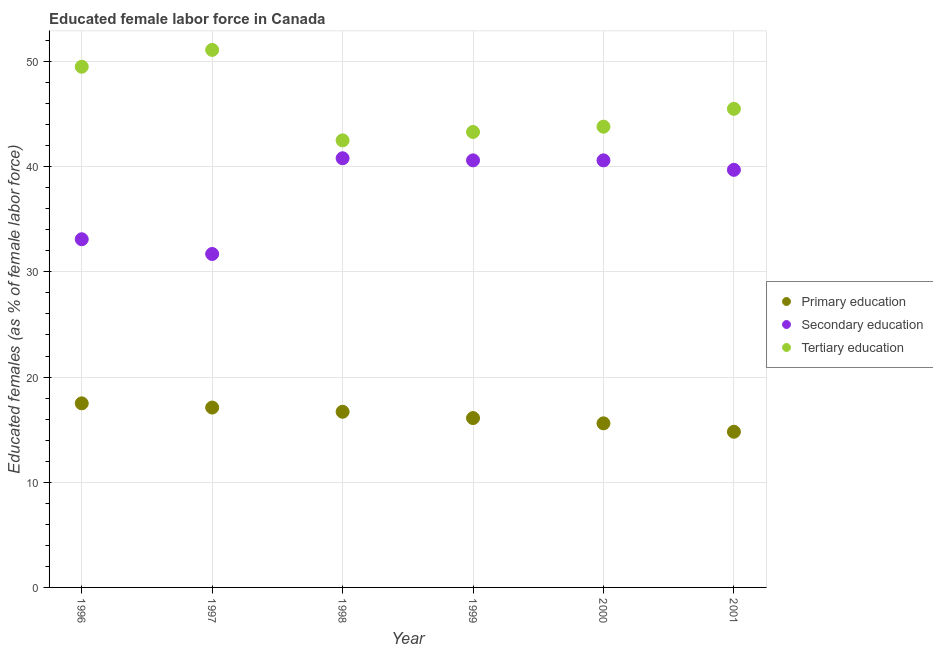Is the number of dotlines equal to the number of legend labels?
Ensure brevity in your answer.  Yes. Across all years, what is the maximum percentage of female labor force who received tertiary education?
Your response must be concise. 51.1. Across all years, what is the minimum percentage of female labor force who received tertiary education?
Ensure brevity in your answer.  42.5. In which year was the percentage of female labor force who received tertiary education maximum?
Offer a very short reply. 1997. What is the total percentage of female labor force who received secondary education in the graph?
Provide a short and direct response. 226.5. What is the difference between the percentage of female labor force who received primary education in 1996 and that in 2001?
Make the answer very short. 2.7. What is the difference between the percentage of female labor force who received tertiary education in 1999 and the percentage of female labor force who received primary education in 1996?
Give a very brief answer. 25.8. What is the average percentage of female labor force who received tertiary education per year?
Provide a short and direct response. 45.95. In the year 2001, what is the difference between the percentage of female labor force who received primary education and percentage of female labor force who received tertiary education?
Ensure brevity in your answer.  -30.7. What is the ratio of the percentage of female labor force who received secondary education in 1997 to that in 1998?
Your response must be concise. 0.78. Is the percentage of female labor force who received primary education in 1997 less than that in 1999?
Your answer should be very brief. No. Is the difference between the percentage of female labor force who received secondary education in 1996 and 2001 greater than the difference between the percentage of female labor force who received tertiary education in 1996 and 2001?
Give a very brief answer. No. What is the difference between the highest and the second highest percentage of female labor force who received secondary education?
Make the answer very short. 0.2. What is the difference between the highest and the lowest percentage of female labor force who received secondary education?
Make the answer very short. 9.1. Is the sum of the percentage of female labor force who received secondary education in 1997 and 2001 greater than the maximum percentage of female labor force who received primary education across all years?
Offer a very short reply. Yes. Does the percentage of female labor force who received secondary education monotonically increase over the years?
Offer a terse response. No. Is the percentage of female labor force who received tertiary education strictly greater than the percentage of female labor force who received secondary education over the years?
Offer a terse response. Yes. Is the percentage of female labor force who received secondary education strictly less than the percentage of female labor force who received tertiary education over the years?
Offer a terse response. Yes. How many dotlines are there?
Your answer should be very brief. 3. How many years are there in the graph?
Make the answer very short. 6. What is the difference between two consecutive major ticks on the Y-axis?
Your answer should be compact. 10. Does the graph contain grids?
Provide a succinct answer. Yes. Where does the legend appear in the graph?
Your answer should be very brief. Center right. What is the title of the graph?
Keep it short and to the point. Educated female labor force in Canada. What is the label or title of the X-axis?
Make the answer very short. Year. What is the label or title of the Y-axis?
Offer a terse response. Educated females (as % of female labor force). What is the Educated females (as % of female labor force) in Secondary education in 1996?
Offer a very short reply. 33.1. What is the Educated females (as % of female labor force) of Tertiary education in 1996?
Offer a very short reply. 49.5. What is the Educated females (as % of female labor force) in Primary education in 1997?
Keep it short and to the point. 17.1. What is the Educated females (as % of female labor force) of Secondary education in 1997?
Your answer should be compact. 31.7. What is the Educated females (as % of female labor force) in Tertiary education in 1997?
Keep it short and to the point. 51.1. What is the Educated females (as % of female labor force) of Primary education in 1998?
Give a very brief answer. 16.7. What is the Educated females (as % of female labor force) in Secondary education in 1998?
Offer a very short reply. 40.8. What is the Educated females (as % of female labor force) of Tertiary education in 1998?
Your answer should be compact. 42.5. What is the Educated females (as % of female labor force) in Primary education in 1999?
Provide a short and direct response. 16.1. What is the Educated females (as % of female labor force) of Secondary education in 1999?
Your response must be concise. 40.6. What is the Educated females (as % of female labor force) in Tertiary education in 1999?
Your response must be concise. 43.3. What is the Educated females (as % of female labor force) in Primary education in 2000?
Give a very brief answer. 15.6. What is the Educated females (as % of female labor force) of Secondary education in 2000?
Your response must be concise. 40.6. What is the Educated females (as % of female labor force) in Tertiary education in 2000?
Give a very brief answer. 43.8. What is the Educated females (as % of female labor force) of Primary education in 2001?
Offer a very short reply. 14.8. What is the Educated females (as % of female labor force) in Secondary education in 2001?
Your response must be concise. 39.7. What is the Educated females (as % of female labor force) of Tertiary education in 2001?
Offer a terse response. 45.5. Across all years, what is the maximum Educated females (as % of female labor force) in Secondary education?
Your answer should be very brief. 40.8. Across all years, what is the maximum Educated females (as % of female labor force) in Tertiary education?
Your answer should be compact. 51.1. Across all years, what is the minimum Educated females (as % of female labor force) in Primary education?
Offer a very short reply. 14.8. Across all years, what is the minimum Educated females (as % of female labor force) of Secondary education?
Your answer should be very brief. 31.7. Across all years, what is the minimum Educated females (as % of female labor force) in Tertiary education?
Offer a terse response. 42.5. What is the total Educated females (as % of female labor force) of Primary education in the graph?
Your answer should be very brief. 97.8. What is the total Educated females (as % of female labor force) in Secondary education in the graph?
Keep it short and to the point. 226.5. What is the total Educated females (as % of female labor force) of Tertiary education in the graph?
Make the answer very short. 275.7. What is the difference between the Educated females (as % of female labor force) in Tertiary education in 1996 and that in 1997?
Your answer should be compact. -1.6. What is the difference between the Educated females (as % of female labor force) in Primary education in 1996 and that in 1998?
Provide a short and direct response. 0.8. What is the difference between the Educated females (as % of female labor force) in Secondary education in 1996 and that in 1998?
Provide a short and direct response. -7.7. What is the difference between the Educated females (as % of female labor force) of Primary education in 1996 and that in 1999?
Your answer should be compact. 1.4. What is the difference between the Educated females (as % of female labor force) of Primary education in 1996 and that in 2000?
Keep it short and to the point. 1.9. What is the difference between the Educated females (as % of female labor force) in Tertiary education in 1996 and that in 2000?
Give a very brief answer. 5.7. What is the difference between the Educated females (as % of female labor force) in Primary education in 1996 and that in 2001?
Your response must be concise. 2.7. What is the difference between the Educated females (as % of female labor force) in Secondary education in 1997 and that in 1998?
Provide a succinct answer. -9.1. What is the difference between the Educated females (as % of female labor force) of Tertiary education in 1997 and that in 1998?
Your answer should be compact. 8.6. What is the difference between the Educated females (as % of female labor force) in Tertiary education in 1997 and that in 1999?
Offer a very short reply. 7.8. What is the difference between the Educated females (as % of female labor force) of Primary education in 1997 and that in 2000?
Give a very brief answer. 1.5. What is the difference between the Educated females (as % of female labor force) of Tertiary education in 1997 and that in 2000?
Make the answer very short. 7.3. What is the difference between the Educated females (as % of female labor force) of Primary education in 1997 and that in 2001?
Give a very brief answer. 2.3. What is the difference between the Educated females (as % of female labor force) of Secondary education in 1997 and that in 2001?
Offer a terse response. -8. What is the difference between the Educated females (as % of female labor force) in Primary education in 1998 and that in 2000?
Your response must be concise. 1.1. What is the difference between the Educated females (as % of female labor force) of Secondary education in 1998 and that in 2000?
Your answer should be compact. 0.2. What is the difference between the Educated females (as % of female labor force) of Tertiary education in 1998 and that in 2000?
Your response must be concise. -1.3. What is the difference between the Educated females (as % of female labor force) in Primary education in 1999 and that in 2000?
Give a very brief answer. 0.5. What is the difference between the Educated females (as % of female labor force) of Secondary education in 1999 and that in 2001?
Your answer should be compact. 0.9. What is the difference between the Educated females (as % of female labor force) in Tertiary education in 1999 and that in 2001?
Provide a succinct answer. -2.2. What is the difference between the Educated females (as % of female labor force) of Primary education in 2000 and that in 2001?
Keep it short and to the point. 0.8. What is the difference between the Educated females (as % of female labor force) of Primary education in 1996 and the Educated females (as % of female labor force) of Secondary education in 1997?
Your answer should be compact. -14.2. What is the difference between the Educated females (as % of female labor force) of Primary education in 1996 and the Educated females (as % of female labor force) of Tertiary education in 1997?
Your response must be concise. -33.6. What is the difference between the Educated females (as % of female labor force) in Secondary education in 1996 and the Educated females (as % of female labor force) in Tertiary education in 1997?
Your answer should be very brief. -18. What is the difference between the Educated females (as % of female labor force) in Primary education in 1996 and the Educated females (as % of female labor force) in Secondary education in 1998?
Ensure brevity in your answer.  -23.3. What is the difference between the Educated females (as % of female labor force) in Secondary education in 1996 and the Educated females (as % of female labor force) in Tertiary education in 1998?
Your answer should be very brief. -9.4. What is the difference between the Educated females (as % of female labor force) in Primary education in 1996 and the Educated females (as % of female labor force) in Secondary education in 1999?
Keep it short and to the point. -23.1. What is the difference between the Educated females (as % of female labor force) in Primary education in 1996 and the Educated females (as % of female labor force) in Tertiary education in 1999?
Offer a very short reply. -25.8. What is the difference between the Educated females (as % of female labor force) in Primary education in 1996 and the Educated females (as % of female labor force) in Secondary education in 2000?
Offer a terse response. -23.1. What is the difference between the Educated females (as % of female labor force) in Primary education in 1996 and the Educated females (as % of female labor force) in Tertiary education in 2000?
Your response must be concise. -26.3. What is the difference between the Educated females (as % of female labor force) in Secondary education in 1996 and the Educated females (as % of female labor force) in Tertiary education in 2000?
Make the answer very short. -10.7. What is the difference between the Educated females (as % of female labor force) in Primary education in 1996 and the Educated females (as % of female labor force) in Secondary education in 2001?
Your answer should be compact. -22.2. What is the difference between the Educated females (as % of female labor force) of Primary education in 1997 and the Educated females (as % of female labor force) of Secondary education in 1998?
Give a very brief answer. -23.7. What is the difference between the Educated females (as % of female labor force) of Primary education in 1997 and the Educated females (as % of female labor force) of Tertiary education in 1998?
Provide a succinct answer. -25.4. What is the difference between the Educated females (as % of female labor force) of Primary education in 1997 and the Educated females (as % of female labor force) of Secondary education in 1999?
Make the answer very short. -23.5. What is the difference between the Educated females (as % of female labor force) of Primary education in 1997 and the Educated females (as % of female labor force) of Tertiary education in 1999?
Keep it short and to the point. -26.2. What is the difference between the Educated females (as % of female labor force) of Secondary education in 1997 and the Educated females (as % of female labor force) of Tertiary education in 1999?
Give a very brief answer. -11.6. What is the difference between the Educated females (as % of female labor force) in Primary education in 1997 and the Educated females (as % of female labor force) in Secondary education in 2000?
Give a very brief answer. -23.5. What is the difference between the Educated females (as % of female labor force) of Primary education in 1997 and the Educated females (as % of female labor force) of Tertiary education in 2000?
Make the answer very short. -26.7. What is the difference between the Educated females (as % of female labor force) of Primary education in 1997 and the Educated females (as % of female labor force) of Secondary education in 2001?
Provide a succinct answer. -22.6. What is the difference between the Educated females (as % of female labor force) of Primary education in 1997 and the Educated females (as % of female labor force) of Tertiary education in 2001?
Your response must be concise. -28.4. What is the difference between the Educated females (as % of female labor force) of Primary education in 1998 and the Educated females (as % of female labor force) of Secondary education in 1999?
Give a very brief answer. -23.9. What is the difference between the Educated females (as % of female labor force) of Primary education in 1998 and the Educated females (as % of female labor force) of Tertiary education in 1999?
Keep it short and to the point. -26.6. What is the difference between the Educated females (as % of female labor force) in Primary education in 1998 and the Educated females (as % of female labor force) in Secondary education in 2000?
Offer a terse response. -23.9. What is the difference between the Educated females (as % of female labor force) in Primary education in 1998 and the Educated females (as % of female labor force) in Tertiary education in 2000?
Give a very brief answer. -27.1. What is the difference between the Educated females (as % of female labor force) in Secondary education in 1998 and the Educated females (as % of female labor force) in Tertiary education in 2000?
Your answer should be very brief. -3. What is the difference between the Educated females (as % of female labor force) of Primary education in 1998 and the Educated females (as % of female labor force) of Tertiary education in 2001?
Offer a terse response. -28.8. What is the difference between the Educated females (as % of female labor force) of Secondary education in 1998 and the Educated females (as % of female labor force) of Tertiary education in 2001?
Make the answer very short. -4.7. What is the difference between the Educated females (as % of female labor force) of Primary education in 1999 and the Educated females (as % of female labor force) of Secondary education in 2000?
Keep it short and to the point. -24.5. What is the difference between the Educated females (as % of female labor force) in Primary education in 1999 and the Educated females (as % of female labor force) in Tertiary education in 2000?
Your answer should be compact. -27.7. What is the difference between the Educated females (as % of female labor force) of Secondary education in 1999 and the Educated females (as % of female labor force) of Tertiary education in 2000?
Make the answer very short. -3.2. What is the difference between the Educated females (as % of female labor force) in Primary education in 1999 and the Educated females (as % of female labor force) in Secondary education in 2001?
Your response must be concise. -23.6. What is the difference between the Educated females (as % of female labor force) of Primary education in 1999 and the Educated females (as % of female labor force) of Tertiary education in 2001?
Offer a terse response. -29.4. What is the difference between the Educated females (as % of female labor force) in Primary education in 2000 and the Educated females (as % of female labor force) in Secondary education in 2001?
Your answer should be compact. -24.1. What is the difference between the Educated females (as % of female labor force) in Primary education in 2000 and the Educated females (as % of female labor force) in Tertiary education in 2001?
Make the answer very short. -29.9. What is the difference between the Educated females (as % of female labor force) in Secondary education in 2000 and the Educated females (as % of female labor force) in Tertiary education in 2001?
Give a very brief answer. -4.9. What is the average Educated females (as % of female labor force) in Secondary education per year?
Ensure brevity in your answer.  37.75. What is the average Educated females (as % of female labor force) of Tertiary education per year?
Make the answer very short. 45.95. In the year 1996, what is the difference between the Educated females (as % of female labor force) of Primary education and Educated females (as % of female labor force) of Secondary education?
Keep it short and to the point. -15.6. In the year 1996, what is the difference between the Educated females (as % of female labor force) in Primary education and Educated females (as % of female labor force) in Tertiary education?
Your answer should be compact. -32. In the year 1996, what is the difference between the Educated females (as % of female labor force) of Secondary education and Educated females (as % of female labor force) of Tertiary education?
Your answer should be very brief. -16.4. In the year 1997, what is the difference between the Educated females (as % of female labor force) of Primary education and Educated females (as % of female labor force) of Secondary education?
Give a very brief answer. -14.6. In the year 1997, what is the difference between the Educated females (as % of female labor force) in Primary education and Educated females (as % of female labor force) in Tertiary education?
Your answer should be compact. -34. In the year 1997, what is the difference between the Educated females (as % of female labor force) in Secondary education and Educated females (as % of female labor force) in Tertiary education?
Provide a short and direct response. -19.4. In the year 1998, what is the difference between the Educated females (as % of female labor force) of Primary education and Educated females (as % of female labor force) of Secondary education?
Provide a short and direct response. -24.1. In the year 1998, what is the difference between the Educated females (as % of female labor force) of Primary education and Educated females (as % of female labor force) of Tertiary education?
Your response must be concise. -25.8. In the year 1999, what is the difference between the Educated females (as % of female labor force) of Primary education and Educated females (as % of female labor force) of Secondary education?
Your answer should be compact. -24.5. In the year 1999, what is the difference between the Educated females (as % of female labor force) of Primary education and Educated females (as % of female labor force) of Tertiary education?
Offer a terse response. -27.2. In the year 1999, what is the difference between the Educated females (as % of female labor force) in Secondary education and Educated females (as % of female labor force) in Tertiary education?
Keep it short and to the point. -2.7. In the year 2000, what is the difference between the Educated females (as % of female labor force) in Primary education and Educated females (as % of female labor force) in Secondary education?
Provide a succinct answer. -25. In the year 2000, what is the difference between the Educated females (as % of female labor force) in Primary education and Educated females (as % of female labor force) in Tertiary education?
Offer a terse response. -28.2. In the year 2000, what is the difference between the Educated females (as % of female labor force) of Secondary education and Educated females (as % of female labor force) of Tertiary education?
Provide a short and direct response. -3.2. In the year 2001, what is the difference between the Educated females (as % of female labor force) of Primary education and Educated females (as % of female labor force) of Secondary education?
Make the answer very short. -24.9. In the year 2001, what is the difference between the Educated females (as % of female labor force) of Primary education and Educated females (as % of female labor force) of Tertiary education?
Your response must be concise. -30.7. What is the ratio of the Educated females (as % of female labor force) of Primary education in 1996 to that in 1997?
Your response must be concise. 1.02. What is the ratio of the Educated females (as % of female labor force) of Secondary education in 1996 to that in 1997?
Give a very brief answer. 1.04. What is the ratio of the Educated females (as % of female labor force) in Tertiary education in 1996 to that in 1997?
Your answer should be very brief. 0.97. What is the ratio of the Educated females (as % of female labor force) of Primary education in 1996 to that in 1998?
Keep it short and to the point. 1.05. What is the ratio of the Educated females (as % of female labor force) in Secondary education in 1996 to that in 1998?
Make the answer very short. 0.81. What is the ratio of the Educated females (as % of female labor force) in Tertiary education in 1996 to that in 1998?
Make the answer very short. 1.16. What is the ratio of the Educated females (as % of female labor force) of Primary education in 1996 to that in 1999?
Your answer should be compact. 1.09. What is the ratio of the Educated females (as % of female labor force) of Secondary education in 1996 to that in 1999?
Your response must be concise. 0.82. What is the ratio of the Educated females (as % of female labor force) in Tertiary education in 1996 to that in 1999?
Keep it short and to the point. 1.14. What is the ratio of the Educated females (as % of female labor force) of Primary education in 1996 to that in 2000?
Offer a very short reply. 1.12. What is the ratio of the Educated females (as % of female labor force) in Secondary education in 1996 to that in 2000?
Make the answer very short. 0.82. What is the ratio of the Educated females (as % of female labor force) of Tertiary education in 1996 to that in 2000?
Make the answer very short. 1.13. What is the ratio of the Educated females (as % of female labor force) of Primary education in 1996 to that in 2001?
Your answer should be compact. 1.18. What is the ratio of the Educated females (as % of female labor force) in Secondary education in 1996 to that in 2001?
Your response must be concise. 0.83. What is the ratio of the Educated females (as % of female labor force) of Tertiary education in 1996 to that in 2001?
Ensure brevity in your answer.  1.09. What is the ratio of the Educated females (as % of female labor force) in Secondary education in 1997 to that in 1998?
Offer a terse response. 0.78. What is the ratio of the Educated females (as % of female labor force) of Tertiary education in 1997 to that in 1998?
Offer a very short reply. 1.2. What is the ratio of the Educated females (as % of female labor force) of Primary education in 1997 to that in 1999?
Make the answer very short. 1.06. What is the ratio of the Educated females (as % of female labor force) of Secondary education in 1997 to that in 1999?
Offer a very short reply. 0.78. What is the ratio of the Educated females (as % of female labor force) in Tertiary education in 1997 to that in 1999?
Make the answer very short. 1.18. What is the ratio of the Educated females (as % of female labor force) of Primary education in 1997 to that in 2000?
Your response must be concise. 1.1. What is the ratio of the Educated females (as % of female labor force) in Secondary education in 1997 to that in 2000?
Your answer should be compact. 0.78. What is the ratio of the Educated females (as % of female labor force) of Primary education in 1997 to that in 2001?
Offer a very short reply. 1.16. What is the ratio of the Educated females (as % of female labor force) in Secondary education in 1997 to that in 2001?
Provide a succinct answer. 0.8. What is the ratio of the Educated females (as % of female labor force) of Tertiary education in 1997 to that in 2001?
Offer a very short reply. 1.12. What is the ratio of the Educated females (as % of female labor force) in Primary education in 1998 to that in 1999?
Provide a short and direct response. 1.04. What is the ratio of the Educated females (as % of female labor force) in Tertiary education in 1998 to that in 1999?
Keep it short and to the point. 0.98. What is the ratio of the Educated females (as % of female labor force) in Primary education in 1998 to that in 2000?
Your answer should be very brief. 1.07. What is the ratio of the Educated females (as % of female labor force) in Secondary education in 1998 to that in 2000?
Give a very brief answer. 1. What is the ratio of the Educated females (as % of female labor force) in Tertiary education in 1998 to that in 2000?
Keep it short and to the point. 0.97. What is the ratio of the Educated females (as % of female labor force) in Primary education in 1998 to that in 2001?
Your answer should be compact. 1.13. What is the ratio of the Educated females (as % of female labor force) in Secondary education in 1998 to that in 2001?
Offer a very short reply. 1.03. What is the ratio of the Educated females (as % of female labor force) of Tertiary education in 1998 to that in 2001?
Your response must be concise. 0.93. What is the ratio of the Educated females (as % of female labor force) of Primary education in 1999 to that in 2000?
Your answer should be very brief. 1.03. What is the ratio of the Educated females (as % of female labor force) of Secondary education in 1999 to that in 2000?
Make the answer very short. 1. What is the ratio of the Educated females (as % of female labor force) in Tertiary education in 1999 to that in 2000?
Offer a terse response. 0.99. What is the ratio of the Educated females (as % of female labor force) in Primary education in 1999 to that in 2001?
Your response must be concise. 1.09. What is the ratio of the Educated females (as % of female labor force) in Secondary education in 1999 to that in 2001?
Keep it short and to the point. 1.02. What is the ratio of the Educated females (as % of female labor force) of Tertiary education in 1999 to that in 2001?
Offer a terse response. 0.95. What is the ratio of the Educated females (as % of female labor force) in Primary education in 2000 to that in 2001?
Your answer should be very brief. 1.05. What is the ratio of the Educated females (as % of female labor force) in Secondary education in 2000 to that in 2001?
Your response must be concise. 1.02. What is the ratio of the Educated females (as % of female labor force) of Tertiary education in 2000 to that in 2001?
Your answer should be compact. 0.96. What is the difference between the highest and the second highest Educated females (as % of female labor force) of Tertiary education?
Your answer should be very brief. 1.6. What is the difference between the highest and the lowest Educated females (as % of female labor force) of Secondary education?
Provide a succinct answer. 9.1. What is the difference between the highest and the lowest Educated females (as % of female labor force) in Tertiary education?
Your answer should be very brief. 8.6. 